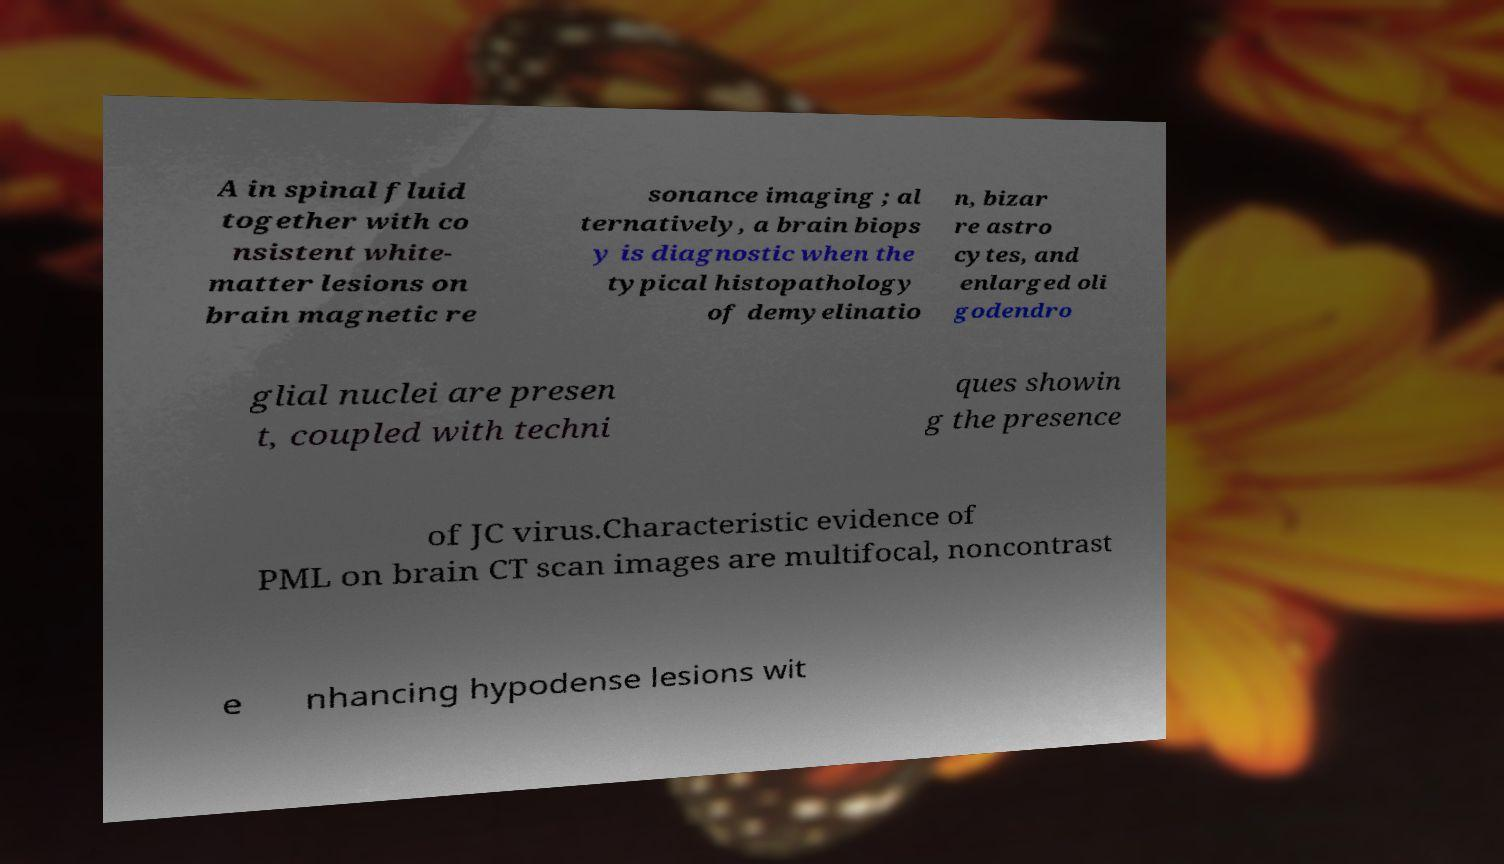Could you extract and type out the text from this image? A in spinal fluid together with co nsistent white- matter lesions on brain magnetic re sonance imaging ; al ternatively, a brain biops y is diagnostic when the typical histopathology of demyelinatio n, bizar re astro cytes, and enlarged oli godendro glial nuclei are presen t, coupled with techni ques showin g the presence of JC virus.Characteristic evidence of PML on brain CT scan images are multifocal, noncontrast e nhancing hypodense lesions wit 